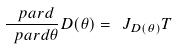Convert formula to latex. <formula><loc_0><loc_0><loc_500><loc_500>\frac { \ p a r d } { \ p a r d \theta } D ( \theta ) = \ J _ { D ( \theta ) } T</formula> 